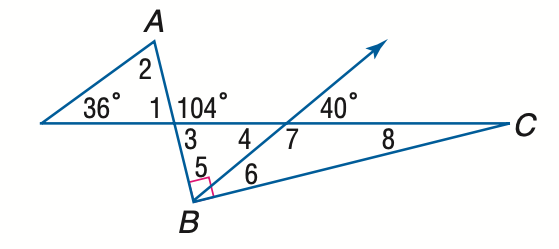Answer the mathemtical geometry problem and directly provide the correct option letter.
Question: Find the measure of \angle 8 if A B \perp B C.
Choices: A: 14 B: 15 C: 16 D: 17 A 